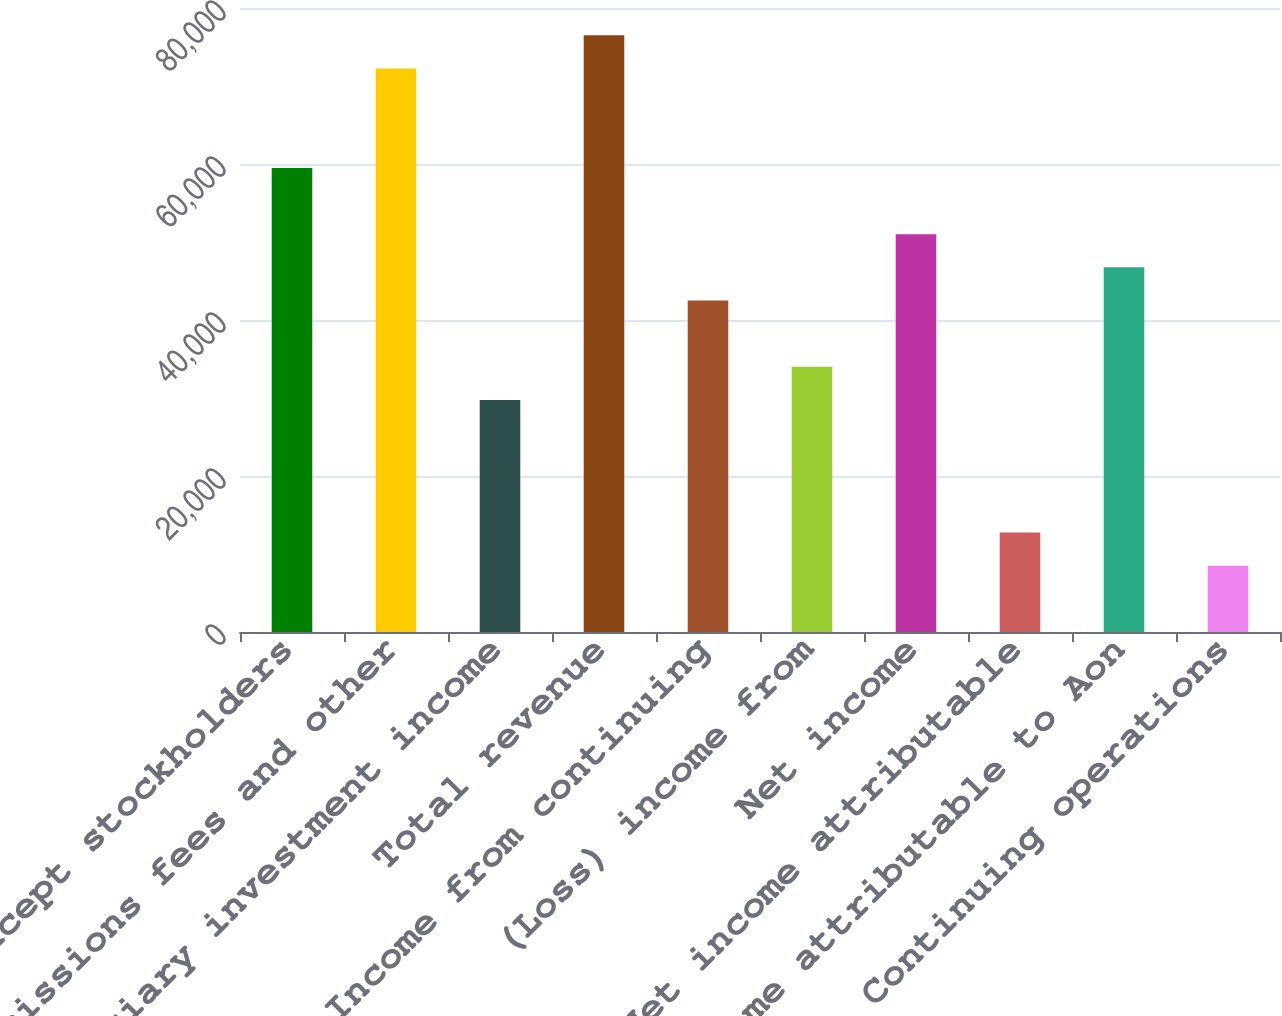Convert chart. <chart><loc_0><loc_0><loc_500><loc_500><bar_chart><fcel>(millions except stockholders<fcel>Commissions fees and other<fcel>Fiduciary investment income<fcel>Total revenue<fcel>Income from continuing<fcel>(Loss) income from<fcel>Net income<fcel>Less Net income attributable<fcel>Net income attributable to Aon<fcel>Continuing operations<nl><fcel>59499.8<fcel>72249.6<fcel>29750.2<fcel>76499.5<fcel>42500<fcel>34000.1<fcel>50999.9<fcel>12750.4<fcel>46749.9<fcel>8500.48<nl></chart> 